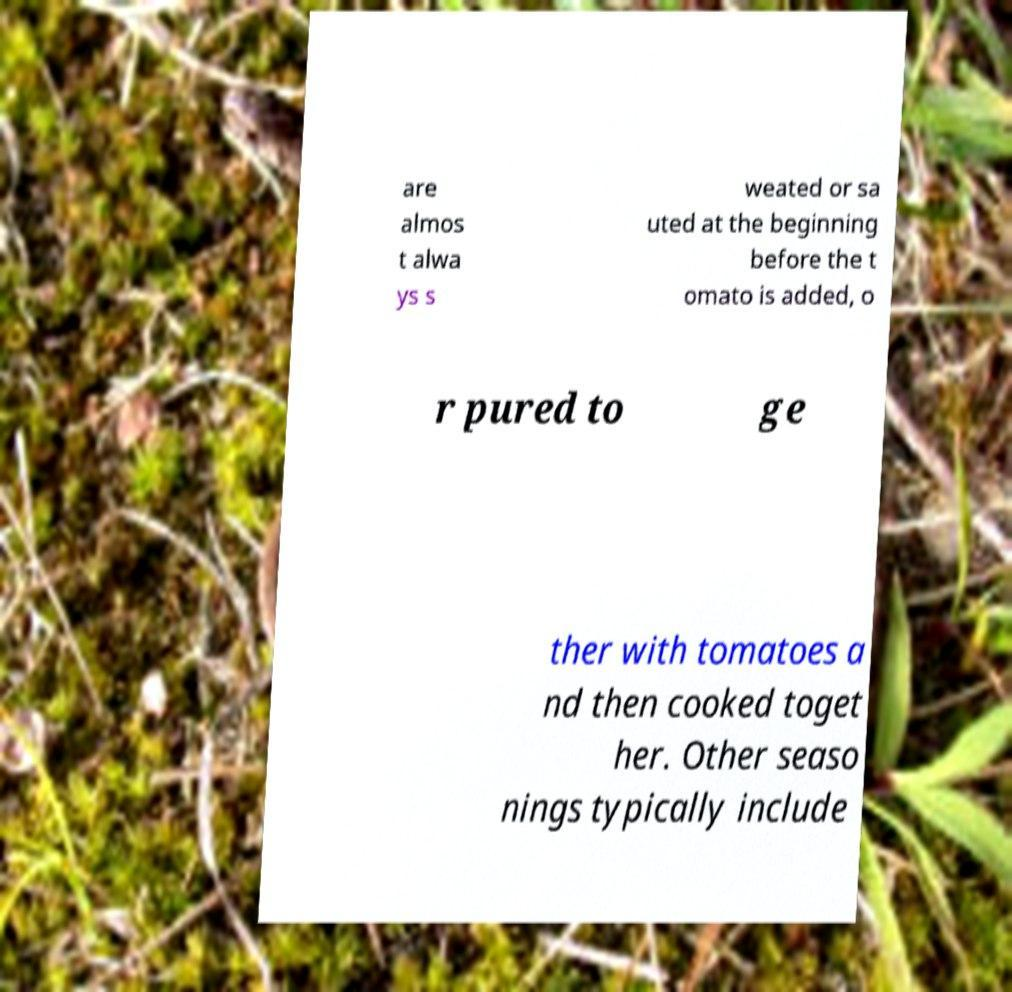I need the written content from this picture converted into text. Can you do that? are almos t alwa ys s weated or sa uted at the beginning before the t omato is added, o r pured to ge ther with tomatoes a nd then cooked toget her. Other seaso nings typically include 